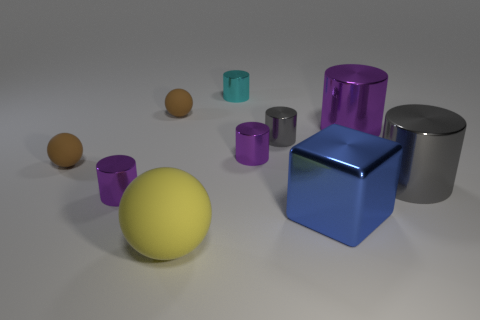Subtract all purple cylinders. How many were subtracted if there are1purple cylinders left? 2 Subtract all red spheres. How many purple cylinders are left? 3 Subtract 2 cylinders. How many cylinders are left? 4 Subtract all cyan cylinders. How many cylinders are left? 5 Subtract all tiny gray shiny cylinders. How many cylinders are left? 5 Subtract all cyan cylinders. Subtract all green cubes. How many cylinders are left? 5 Subtract all spheres. How many objects are left? 7 Subtract all large blue metal cubes. Subtract all large purple spheres. How many objects are left? 9 Add 8 large shiny cylinders. How many large shiny cylinders are left? 10 Add 5 balls. How many balls exist? 8 